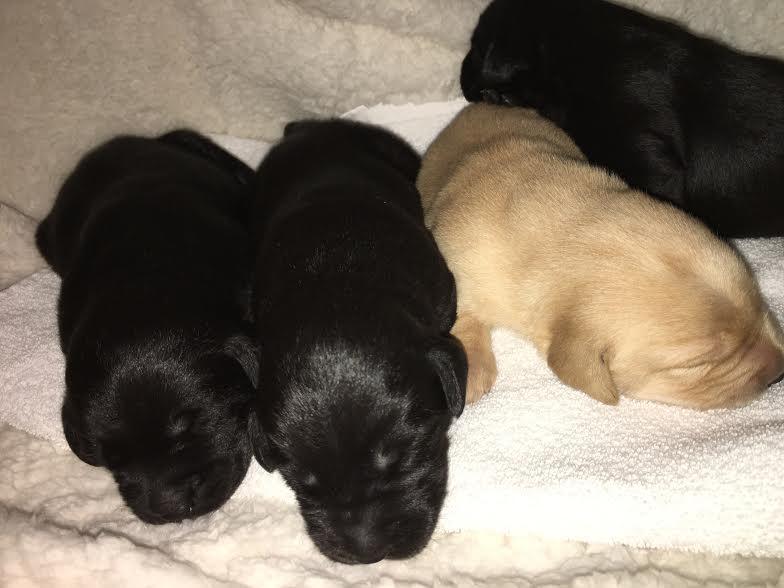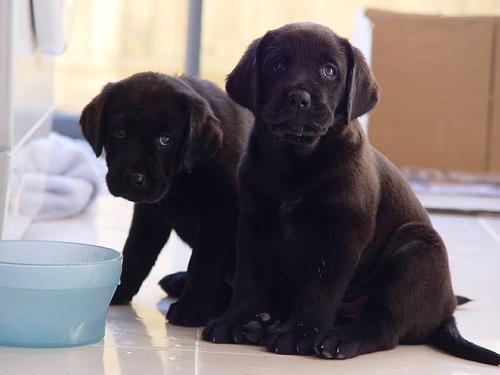The first image is the image on the left, the second image is the image on the right. Evaluate the accuracy of this statement regarding the images: "The left image contains no more than one dog.". Is it true? Answer yes or no. No. The first image is the image on the left, the second image is the image on the right. Given the left and right images, does the statement "An image featuring reclining labrador retrievers includes one """"blond"""" dog." hold true? Answer yes or no. Yes. 